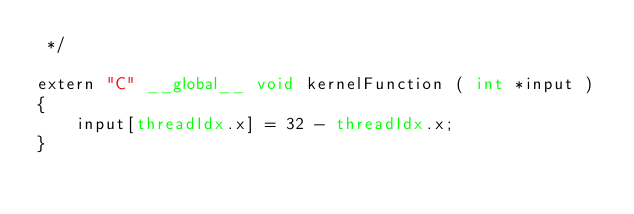<code> <loc_0><loc_0><loc_500><loc_500><_Cuda_> */

extern "C" __global__ void kernelFunction ( int *input )
{
    input[threadIdx.x] = 32 - threadIdx.x;
}
</code> 